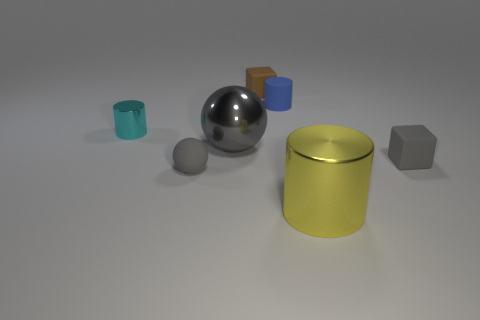Subtract 1 cylinders. How many cylinders are left? 2 Add 2 tiny cyan shiny cylinders. How many objects exist? 9 Subtract all tiny gray shiny blocks. Subtract all small gray rubber balls. How many objects are left? 6 Add 4 metallic objects. How many metallic objects are left? 7 Add 7 green metal objects. How many green metal objects exist? 7 Subtract 0 yellow blocks. How many objects are left? 7 Subtract all cylinders. How many objects are left? 4 Subtract all red cylinders. Subtract all brown blocks. How many cylinders are left? 3 